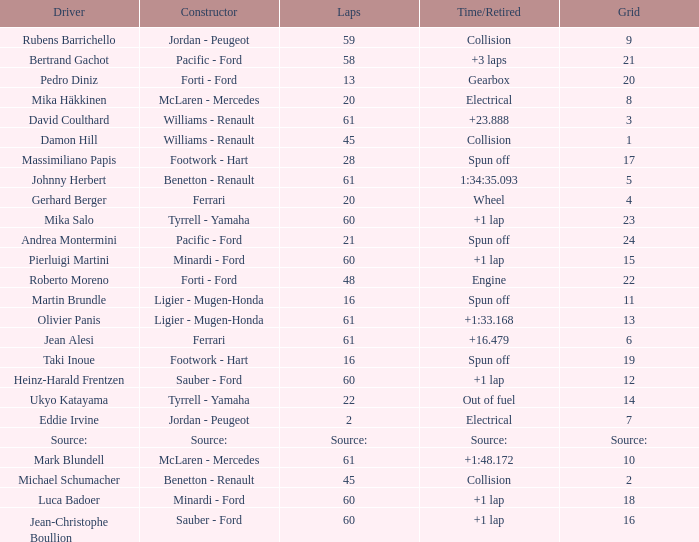How many laps does jean-christophe boullion have with a time/retired of +1 lap? 60.0. I'm looking to parse the entire table for insights. Could you assist me with that? {'header': ['Driver', 'Constructor', 'Laps', 'Time/Retired', 'Grid'], 'rows': [['Rubens Barrichello', 'Jordan - Peugeot', '59', 'Collision', '9'], ['Bertrand Gachot', 'Pacific - Ford', '58', '+3 laps', '21'], ['Pedro Diniz', 'Forti - Ford', '13', 'Gearbox', '20'], ['Mika Häkkinen', 'McLaren - Mercedes', '20', 'Electrical', '8'], ['David Coulthard', 'Williams - Renault', '61', '+23.888', '3'], ['Damon Hill', 'Williams - Renault', '45', 'Collision', '1'], ['Massimiliano Papis', 'Footwork - Hart', '28', 'Spun off', '17'], ['Johnny Herbert', 'Benetton - Renault', '61', '1:34:35.093', '5'], ['Gerhard Berger', 'Ferrari', '20', 'Wheel', '4'], ['Mika Salo', 'Tyrrell - Yamaha', '60', '+1 lap', '23'], ['Andrea Montermini', 'Pacific - Ford', '21', 'Spun off', '24'], ['Pierluigi Martini', 'Minardi - Ford', '60', '+1 lap', '15'], ['Roberto Moreno', 'Forti - Ford', '48', 'Engine', '22'], ['Martin Brundle', 'Ligier - Mugen-Honda', '16', 'Spun off', '11'], ['Olivier Panis', 'Ligier - Mugen-Honda', '61', '+1:33.168', '13'], ['Jean Alesi', 'Ferrari', '61', '+16.479', '6'], ['Taki Inoue', 'Footwork - Hart', '16', 'Spun off', '19'], ['Heinz-Harald Frentzen', 'Sauber - Ford', '60', '+1 lap', '12'], ['Ukyo Katayama', 'Tyrrell - Yamaha', '22', 'Out of fuel', '14'], ['Eddie Irvine', 'Jordan - Peugeot', '2', 'Electrical', '7'], ['Source:', 'Source:', 'Source:', 'Source:', 'Source:'], ['Mark Blundell', 'McLaren - Mercedes', '61', '+1:48.172', '10'], ['Michael Schumacher', 'Benetton - Renault', '45', 'Collision', '2'], ['Luca Badoer', 'Minardi - Ford', '60', '+1 lap', '18'], ['Jean-Christophe Boullion', 'Sauber - Ford', '60', '+1 lap', '16']]} 